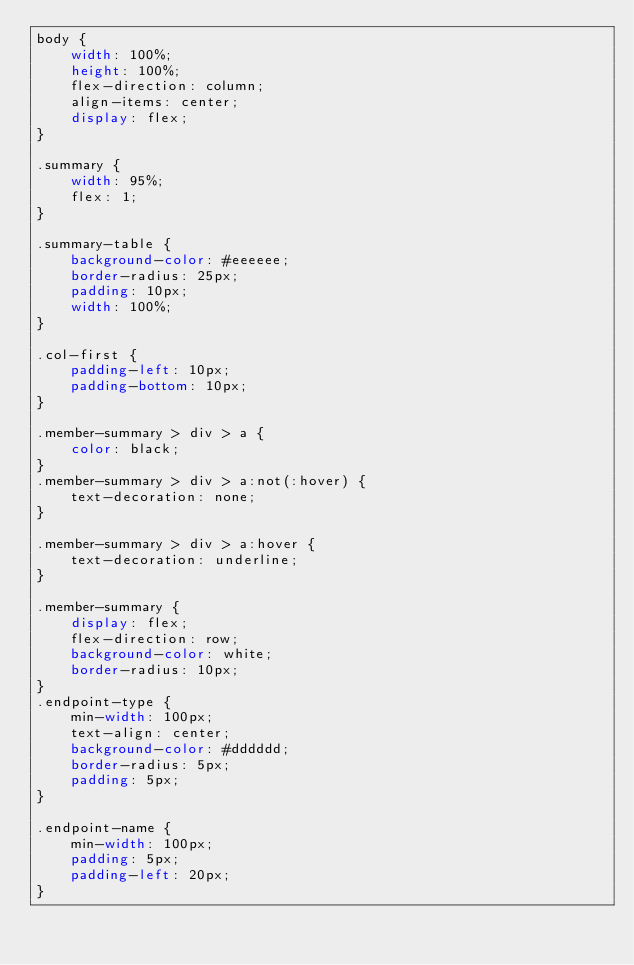Convert code to text. <code><loc_0><loc_0><loc_500><loc_500><_CSS_>body {
    width: 100%;
    height: 100%;
    flex-direction: column;
    align-items: center;
    display: flex;
}

.summary {
    width: 95%;
    flex: 1;
}

.summary-table {
    background-color: #eeeeee;
    border-radius: 25px;
    padding: 10px;
    width: 100%;
}

.col-first {
    padding-left: 10px;
    padding-bottom: 10px;
}

.member-summary > div > a {
    color: black;
}
.member-summary > div > a:not(:hover) {
    text-decoration: none;
}

.member-summary > div > a:hover {
    text-decoration: underline;
}

.member-summary {
    display: flex;
    flex-direction: row;
    background-color: white;
    border-radius: 10px;
}
.endpoint-type {
    min-width: 100px;
    text-align: center;
    background-color: #dddddd;
    border-radius: 5px;
    padding: 5px;
}

.endpoint-name {
    min-width: 100px;
    padding: 5px;
    padding-left: 20px;
}</code> 